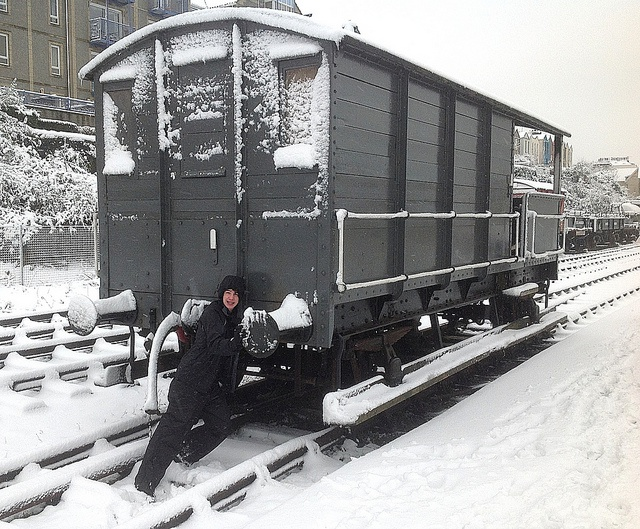Describe the objects in this image and their specific colors. I can see train in gray, black, lightgray, and darkgray tones and people in gray, black, and darkgray tones in this image. 